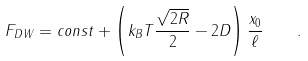<formula> <loc_0><loc_0><loc_500><loc_500>F _ { D W } = c o n s t + \left ( k _ { B } T \frac { \sqrt { 2 R } } { 2 } - 2 D \right ) \frac { x _ { 0 } } { \ell } \quad .</formula> 